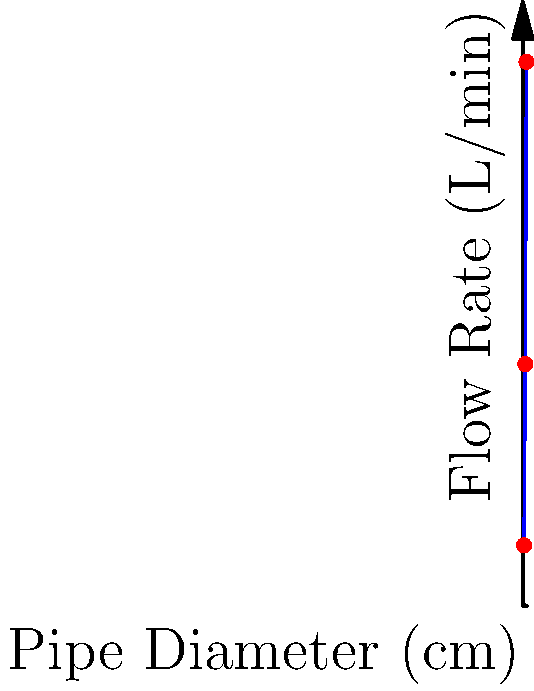As our corporation expands into new markets, we're analyzing fluid flow rates through pipes of varying diameters. The graph shows the relationship between pipe diameter and flow rate for a constant pressure drop. If we need to increase our current flow rate of 400 L/min to 900 L/min to meet growing demand, by how much should we increase the pipe diameter? To solve this problem, we'll follow these steps:

1. Identify the current situation:
   - Current flow rate: 400 L/min
   - Current pipe diameter: 4 cm (from the graph)

2. Identify the target situation:
   - Target flow rate: 900 L/min
   - Target pipe diameter: To be determined

3. Analyze the graph:
   - At 900 L/min, the pipe diameter is 6 cm

4. Calculate the required increase in diameter:
   $$\text{Increase} = \text{Target diameter} - \text{Current diameter}$$
   $$\text{Increase} = 6 \text{ cm} - 4 \text{ cm} = 2 \text{ cm}$$

5. Verify the result:
   - The graph shows that increasing the diameter from 4 cm to 6 cm indeed increases the flow rate from 400 L/min to 900 L/min.

This solution assumes a constant pressure drop across all pipe diameters. In real-world scenarios, factors such as fluid viscosity, pipe roughness, and flow regime (laminar or turbulent) would also need to be considered for a more accurate analysis.
Answer: 2 cm 